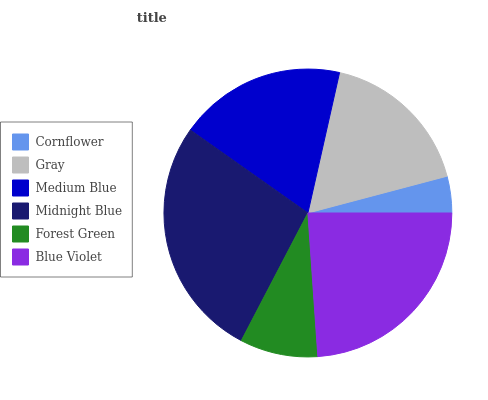Is Cornflower the minimum?
Answer yes or no. Yes. Is Midnight Blue the maximum?
Answer yes or no. Yes. Is Gray the minimum?
Answer yes or no. No. Is Gray the maximum?
Answer yes or no. No. Is Gray greater than Cornflower?
Answer yes or no. Yes. Is Cornflower less than Gray?
Answer yes or no. Yes. Is Cornflower greater than Gray?
Answer yes or no. No. Is Gray less than Cornflower?
Answer yes or no. No. Is Medium Blue the high median?
Answer yes or no. Yes. Is Gray the low median?
Answer yes or no. Yes. Is Blue Violet the high median?
Answer yes or no. No. Is Forest Green the low median?
Answer yes or no. No. 